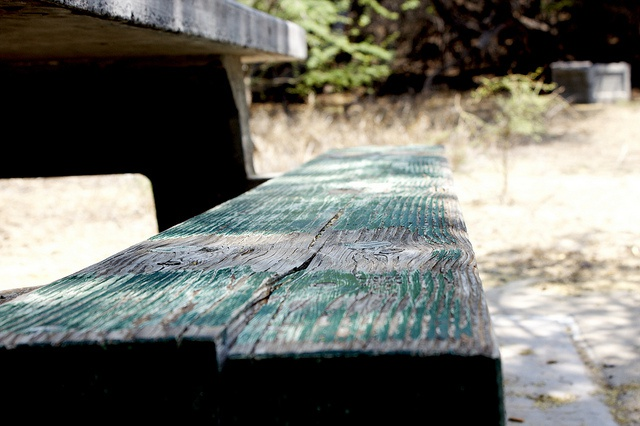Describe the objects in this image and their specific colors. I can see a bench in black, darkgray, gray, and lightgray tones in this image. 